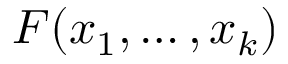Convert formula to latex. <formula><loc_0><loc_0><loc_500><loc_500>F ( x _ { 1 } , \dots , x _ { k } )</formula> 